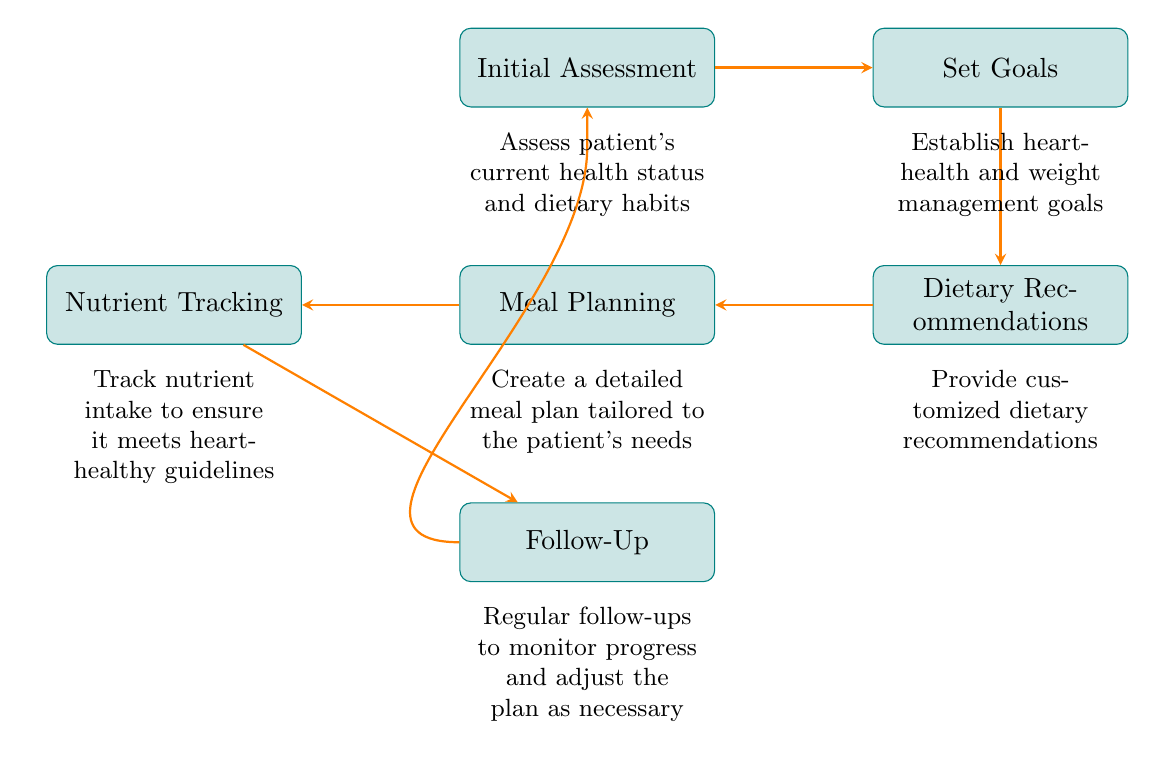What is the first step in the heart-healthy meal planning process? The diagram indicates that the first step is "Initial Assessment." This is the starting point before any other actions are taken in the process.
Answer: Initial Assessment How many nodes are in the diagram? By counting the defined elements in the diagram, we identify six unique nodes: Initial Assessment, Set Goals, Dietary Recommendations, Meal Planning, Nutrient Tracking, and Follow-Up.
Answer: 6 What comes after "Set Goals"? Based on the flow of the diagram, "Set Goals" directly leads to "Dietary Recommendations," which is the following step in the process.
Answer: Dietary Recommendations What is the purpose of the "Follow-Up" node? The "Follow-Up" node serves the purpose of monitoring progress and making adjustments to the meal plan as necessary, ensuring the patient stays on track.
Answer: Monitor progress What is the last step before "Follow-Up"? The diagram shows that the last step before "Follow-Up" is "Nutrient Tracking." This step involves overseeing nutrient intake to align with heart-healthy guidelines.
Answer: Nutrient Tracking Which node provides customized dietary recommendations? The node that provides customized dietary recommendations is labeled "Dietary Recommendations," making this the correct answer regarding what is offered at this stage.
Answer: Dietary Recommendations How does the flowchart cycle back to the beginning? The flowchart cycles back to the beginning from the "Follow-Up" node, indicating that regular follow-ups lead back to the "Initial Assessment" for continuous improvement.
Answer: Initial Assessment 